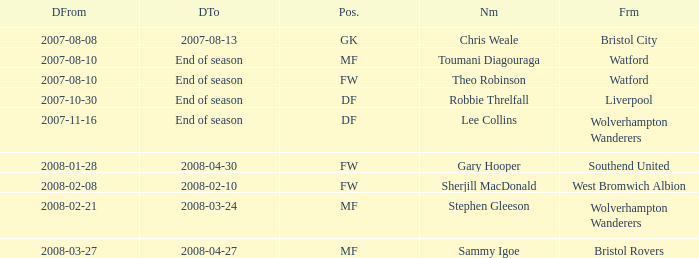What was the from for the Date From of 2007-08-08? Bristol City. 